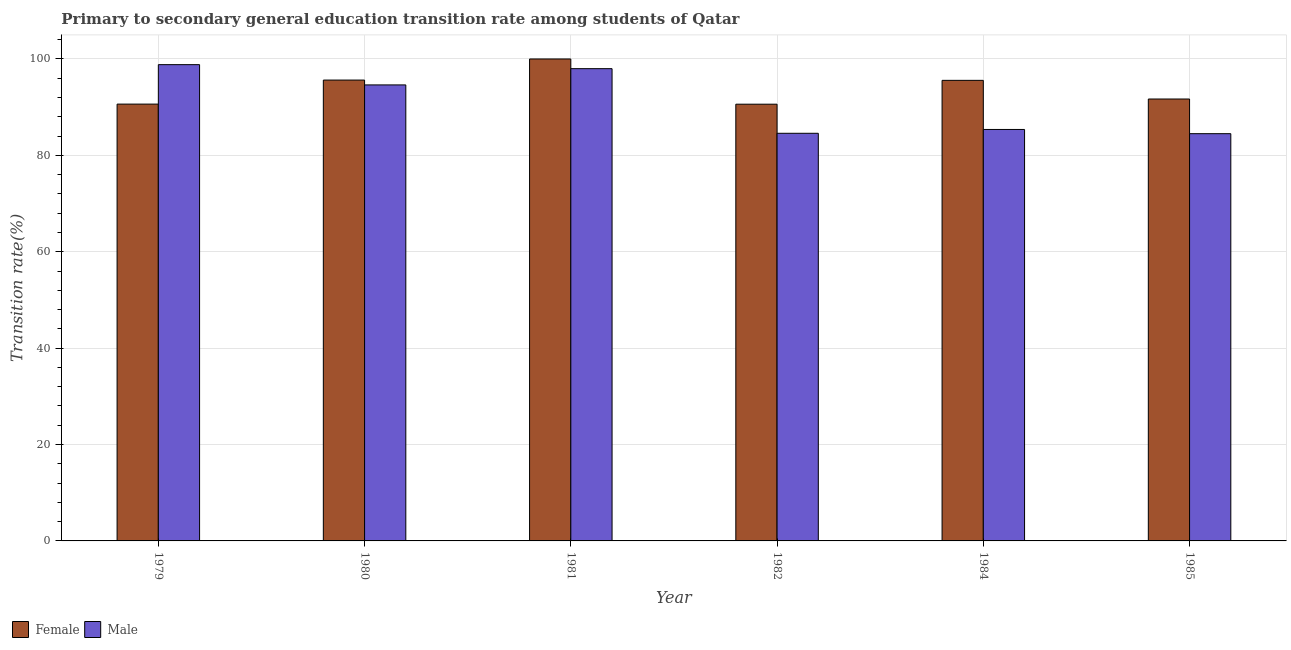How many different coloured bars are there?
Provide a succinct answer. 2. How many groups of bars are there?
Offer a terse response. 6. Are the number of bars per tick equal to the number of legend labels?
Your response must be concise. Yes. Are the number of bars on each tick of the X-axis equal?
Offer a very short reply. Yes. How many bars are there on the 2nd tick from the left?
Your answer should be compact. 2. What is the label of the 3rd group of bars from the left?
Your answer should be very brief. 1981. In how many cases, is the number of bars for a given year not equal to the number of legend labels?
Your answer should be compact. 0. What is the transition rate among female students in 1984?
Ensure brevity in your answer.  95.56. Across all years, what is the minimum transition rate among male students?
Your answer should be compact. 84.5. In which year was the transition rate among female students maximum?
Your response must be concise. 1981. In which year was the transition rate among female students minimum?
Give a very brief answer. 1982. What is the total transition rate among male students in the graph?
Provide a succinct answer. 545.88. What is the difference between the transition rate among female students in 1980 and that in 1985?
Your response must be concise. 3.93. What is the difference between the transition rate among male students in 1979 and the transition rate among female students in 1985?
Provide a succinct answer. 14.32. What is the average transition rate among female students per year?
Keep it short and to the point. 94.02. In the year 1985, what is the difference between the transition rate among female students and transition rate among male students?
Your answer should be compact. 0. In how many years, is the transition rate among female students greater than 16 %?
Provide a short and direct response. 6. What is the ratio of the transition rate among female students in 1979 to that in 1984?
Provide a succinct answer. 0.95. Is the transition rate among male students in 1980 less than that in 1985?
Make the answer very short. No. Is the difference between the transition rate among male students in 1979 and 1981 greater than the difference between the transition rate among female students in 1979 and 1981?
Keep it short and to the point. No. What is the difference between the highest and the second highest transition rate among male students?
Offer a terse response. 0.83. What is the difference between the highest and the lowest transition rate among female students?
Give a very brief answer. 9.38. Is the sum of the transition rate among female students in 1980 and 1985 greater than the maximum transition rate among male students across all years?
Give a very brief answer. Yes. What is the difference between two consecutive major ticks on the Y-axis?
Give a very brief answer. 20. Are the values on the major ticks of Y-axis written in scientific E-notation?
Your answer should be compact. No. Does the graph contain grids?
Ensure brevity in your answer.  Yes. Where does the legend appear in the graph?
Your response must be concise. Bottom left. How many legend labels are there?
Your answer should be compact. 2. What is the title of the graph?
Make the answer very short. Primary to secondary general education transition rate among students of Qatar. Does "Quality of trade" appear as one of the legend labels in the graph?
Your answer should be compact. No. What is the label or title of the Y-axis?
Make the answer very short. Transition rate(%). What is the Transition rate(%) in Female in 1979?
Provide a short and direct response. 90.64. What is the Transition rate(%) in Male in 1979?
Offer a very short reply. 98.82. What is the Transition rate(%) in Female in 1980?
Ensure brevity in your answer.  95.62. What is the Transition rate(%) in Male in 1980?
Your answer should be very brief. 94.62. What is the Transition rate(%) of Male in 1981?
Offer a very short reply. 97.99. What is the Transition rate(%) in Female in 1982?
Your answer should be very brief. 90.62. What is the Transition rate(%) of Male in 1982?
Your response must be concise. 84.58. What is the Transition rate(%) in Female in 1984?
Make the answer very short. 95.56. What is the Transition rate(%) in Male in 1984?
Your answer should be compact. 85.37. What is the Transition rate(%) in Female in 1985?
Provide a succinct answer. 91.69. What is the Transition rate(%) in Male in 1985?
Give a very brief answer. 84.5. Across all years, what is the maximum Transition rate(%) in Male?
Your response must be concise. 98.82. Across all years, what is the minimum Transition rate(%) of Female?
Offer a very short reply. 90.62. Across all years, what is the minimum Transition rate(%) in Male?
Your response must be concise. 84.5. What is the total Transition rate(%) of Female in the graph?
Keep it short and to the point. 564.14. What is the total Transition rate(%) of Male in the graph?
Offer a terse response. 545.88. What is the difference between the Transition rate(%) of Female in 1979 and that in 1980?
Offer a terse response. -4.99. What is the difference between the Transition rate(%) in Male in 1979 and that in 1980?
Offer a terse response. 4.2. What is the difference between the Transition rate(%) of Female in 1979 and that in 1981?
Make the answer very short. -9.36. What is the difference between the Transition rate(%) of Male in 1979 and that in 1981?
Provide a succinct answer. 0.83. What is the difference between the Transition rate(%) in Female in 1979 and that in 1982?
Keep it short and to the point. 0.02. What is the difference between the Transition rate(%) of Male in 1979 and that in 1982?
Your answer should be compact. 14.24. What is the difference between the Transition rate(%) of Female in 1979 and that in 1984?
Your answer should be compact. -4.93. What is the difference between the Transition rate(%) of Male in 1979 and that in 1984?
Make the answer very short. 13.45. What is the difference between the Transition rate(%) in Female in 1979 and that in 1985?
Ensure brevity in your answer.  -1.05. What is the difference between the Transition rate(%) in Male in 1979 and that in 1985?
Provide a short and direct response. 14.32. What is the difference between the Transition rate(%) in Female in 1980 and that in 1981?
Your response must be concise. -4.38. What is the difference between the Transition rate(%) of Male in 1980 and that in 1981?
Your response must be concise. -3.37. What is the difference between the Transition rate(%) of Female in 1980 and that in 1982?
Ensure brevity in your answer.  5.01. What is the difference between the Transition rate(%) of Male in 1980 and that in 1982?
Provide a succinct answer. 10.04. What is the difference between the Transition rate(%) of Female in 1980 and that in 1984?
Give a very brief answer. 0.06. What is the difference between the Transition rate(%) in Male in 1980 and that in 1984?
Your response must be concise. 9.24. What is the difference between the Transition rate(%) of Female in 1980 and that in 1985?
Provide a succinct answer. 3.93. What is the difference between the Transition rate(%) of Male in 1980 and that in 1985?
Your answer should be compact. 10.12. What is the difference between the Transition rate(%) of Female in 1981 and that in 1982?
Give a very brief answer. 9.38. What is the difference between the Transition rate(%) in Male in 1981 and that in 1982?
Ensure brevity in your answer.  13.41. What is the difference between the Transition rate(%) of Female in 1981 and that in 1984?
Your answer should be compact. 4.44. What is the difference between the Transition rate(%) of Male in 1981 and that in 1984?
Your answer should be compact. 12.62. What is the difference between the Transition rate(%) in Female in 1981 and that in 1985?
Provide a succinct answer. 8.31. What is the difference between the Transition rate(%) of Male in 1981 and that in 1985?
Your answer should be very brief. 13.49. What is the difference between the Transition rate(%) in Female in 1982 and that in 1984?
Give a very brief answer. -4.95. What is the difference between the Transition rate(%) of Male in 1982 and that in 1984?
Your answer should be compact. -0.79. What is the difference between the Transition rate(%) in Female in 1982 and that in 1985?
Your response must be concise. -1.07. What is the difference between the Transition rate(%) in Male in 1982 and that in 1985?
Your response must be concise. 0.08. What is the difference between the Transition rate(%) in Female in 1984 and that in 1985?
Provide a succinct answer. 3.87. What is the difference between the Transition rate(%) of Male in 1984 and that in 1985?
Provide a short and direct response. 0.88. What is the difference between the Transition rate(%) in Female in 1979 and the Transition rate(%) in Male in 1980?
Your answer should be very brief. -3.98. What is the difference between the Transition rate(%) in Female in 1979 and the Transition rate(%) in Male in 1981?
Your response must be concise. -7.35. What is the difference between the Transition rate(%) in Female in 1979 and the Transition rate(%) in Male in 1982?
Offer a terse response. 6.06. What is the difference between the Transition rate(%) of Female in 1979 and the Transition rate(%) of Male in 1984?
Your response must be concise. 5.26. What is the difference between the Transition rate(%) in Female in 1979 and the Transition rate(%) in Male in 1985?
Your answer should be compact. 6.14. What is the difference between the Transition rate(%) in Female in 1980 and the Transition rate(%) in Male in 1981?
Offer a terse response. -2.37. What is the difference between the Transition rate(%) in Female in 1980 and the Transition rate(%) in Male in 1982?
Give a very brief answer. 11.04. What is the difference between the Transition rate(%) of Female in 1980 and the Transition rate(%) of Male in 1984?
Make the answer very short. 10.25. What is the difference between the Transition rate(%) of Female in 1980 and the Transition rate(%) of Male in 1985?
Your response must be concise. 11.13. What is the difference between the Transition rate(%) in Female in 1981 and the Transition rate(%) in Male in 1982?
Your answer should be compact. 15.42. What is the difference between the Transition rate(%) of Female in 1981 and the Transition rate(%) of Male in 1984?
Give a very brief answer. 14.63. What is the difference between the Transition rate(%) in Female in 1981 and the Transition rate(%) in Male in 1985?
Provide a short and direct response. 15.5. What is the difference between the Transition rate(%) in Female in 1982 and the Transition rate(%) in Male in 1984?
Provide a succinct answer. 5.24. What is the difference between the Transition rate(%) in Female in 1982 and the Transition rate(%) in Male in 1985?
Offer a terse response. 6.12. What is the difference between the Transition rate(%) in Female in 1984 and the Transition rate(%) in Male in 1985?
Keep it short and to the point. 11.07. What is the average Transition rate(%) of Female per year?
Your answer should be very brief. 94.02. What is the average Transition rate(%) in Male per year?
Provide a short and direct response. 90.98. In the year 1979, what is the difference between the Transition rate(%) of Female and Transition rate(%) of Male?
Offer a terse response. -8.18. In the year 1980, what is the difference between the Transition rate(%) of Female and Transition rate(%) of Male?
Your response must be concise. 1.01. In the year 1981, what is the difference between the Transition rate(%) of Female and Transition rate(%) of Male?
Provide a succinct answer. 2.01. In the year 1982, what is the difference between the Transition rate(%) of Female and Transition rate(%) of Male?
Give a very brief answer. 6.04. In the year 1984, what is the difference between the Transition rate(%) in Female and Transition rate(%) in Male?
Keep it short and to the point. 10.19. In the year 1985, what is the difference between the Transition rate(%) of Female and Transition rate(%) of Male?
Provide a short and direct response. 7.19. What is the ratio of the Transition rate(%) in Female in 1979 to that in 1980?
Ensure brevity in your answer.  0.95. What is the ratio of the Transition rate(%) of Male in 1979 to that in 1980?
Make the answer very short. 1.04. What is the ratio of the Transition rate(%) of Female in 1979 to that in 1981?
Offer a terse response. 0.91. What is the ratio of the Transition rate(%) of Male in 1979 to that in 1981?
Ensure brevity in your answer.  1.01. What is the ratio of the Transition rate(%) in Male in 1979 to that in 1982?
Your answer should be compact. 1.17. What is the ratio of the Transition rate(%) in Female in 1979 to that in 1984?
Your answer should be compact. 0.95. What is the ratio of the Transition rate(%) of Male in 1979 to that in 1984?
Keep it short and to the point. 1.16. What is the ratio of the Transition rate(%) in Female in 1979 to that in 1985?
Provide a short and direct response. 0.99. What is the ratio of the Transition rate(%) of Male in 1979 to that in 1985?
Give a very brief answer. 1.17. What is the ratio of the Transition rate(%) in Female in 1980 to that in 1981?
Your answer should be very brief. 0.96. What is the ratio of the Transition rate(%) in Male in 1980 to that in 1981?
Your answer should be compact. 0.97. What is the ratio of the Transition rate(%) in Female in 1980 to that in 1982?
Offer a terse response. 1.06. What is the ratio of the Transition rate(%) in Male in 1980 to that in 1982?
Provide a succinct answer. 1.12. What is the ratio of the Transition rate(%) in Female in 1980 to that in 1984?
Give a very brief answer. 1. What is the ratio of the Transition rate(%) of Male in 1980 to that in 1984?
Keep it short and to the point. 1.11. What is the ratio of the Transition rate(%) in Female in 1980 to that in 1985?
Provide a succinct answer. 1.04. What is the ratio of the Transition rate(%) in Male in 1980 to that in 1985?
Provide a succinct answer. 1.12. What is the ratio of the Transition rate(%) in Female in 1981 to that in 1982?
Provide a succinct answer. 1.1. What is the ratio of the Transition rate(%) of Male in 1981 to that in 1982?
Offer a terse response. 1.16. What is the ratio of the Transition rate(%) in Female in 1981 to that in 1984?
Provide a succinct answer. 1.05. What is the ratio of the Transition rate(%) in Male in 1981 to that in 1984?
Offer a very short reply. 1.15. What is the ratio of the Transition rate(%) of Female in 1981 to that in 1985?
Offer a terse response. 1.09. What is the ratio of the Transition rate(%) of Male in 1981 to that in 1985?
Your answer should be compact. 1.16. What is the ratio of the Transition rate(%) of Female in 1982 to that in 1984?
Your response must be concise. 0.95. What is the ratio of the Transition rate(%) in Male in 1982 to that in 1984?
Provide a short and direct response. 0.99. What is the ratio of the Transition rate(%) of Female in 1982 to that in 1985?
Make the answer very short. 0.99. What is the ratio of the Transition rate(%) of Male in 1982 to that in 1985?
Provide a succinct answer. 1. What is the ratio of the Transition rate(%) of Female in 1984 to that in 1985?
Your answer should be compact. 1.04. What is the ratio of the Transition rate(%) of Male in 1984 to that in 1985?
Provide a succinct answer. 1.01. What is the difference between the highest and the second highest Transition rate(%) of Female?
Give a very brief answer. 4.38. What is the difference between the highest and the second highest Transition rate(%) in Male?
Your answer should be compact. 0.83. What is the difference between the highest and the lowest Transition rate(%) in Female?
Offer a very short reply. 9.38. What is the difference between the highest and the lowest Transition rate(%) of Male?
Your response must be concise. 14.32. 